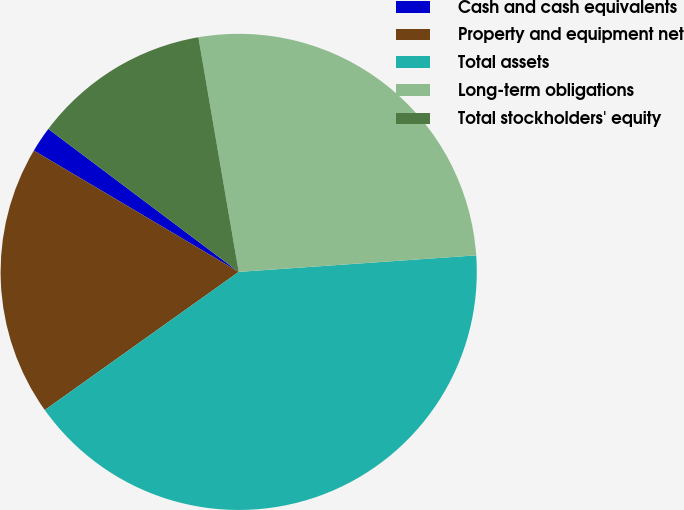Convert chart to OTSL. <chart><loc_0><loc_0><loc_500><loc_500><pie_chart><fcel>Cash and cash equivalents<fcel>Property and equipment net<fcel>Total assets<fcel>Long-term obligations<fcel>Total stockholders' equity<nl><fcel>1.74%<fcel>18.36%<fcel>41.25%<fcel>26.6%<fcel>12.04%<nl></chart> 